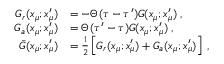Convert formula to latex. <formula><loc_0><loc_0><loc_500><loc_500>\begin{array} { r l } { G _ { r } ( x _ { \mu } ; x _ { \mu } ^ { \prime } ) } & { = - \Theta ( \tau - \tau ^ { \prime } ) G ( x _ { \mu } ; x _ { \mu } ^ { \prime } ) \, , } \\ { G _ { a } ( x _ { \mu } ; x _ { \mu } ^ { \prime } ) } & { = \Theta ( \tau ^ { \prime } - \tau ) G ( x _ { \mu } ; x _ { \mu } ^ { \prime } ) \, , } \\ { \bar { G } ( x _ { \mu } ; x _ { \mu } ^ { \prime } ) } & { = \frac { 1 } { 2 } \left [ G _ { r } ( x _ { \mu } ; x _ { \mu } ^ { \prime } ) + G _ { a } ( x _ { \mu } ; x _ { \mu } ^ { \prime } ) \right ] \, , } \end{array}</formula> 